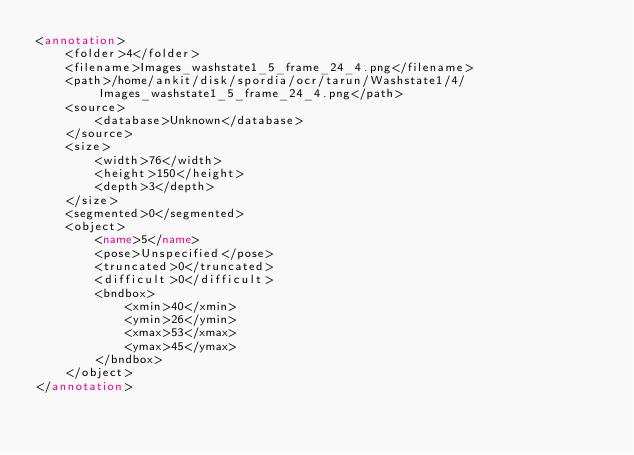<code> <loc_0><loc_0><loc_500><loc_500><_XML_><annotation>
	<folder>4</folder>
	<filename>Images_washstate1_5_frame_24_4.png</filename>
	<path>/home/ankit/disk/spordia/ocr/tarun/Washstate1/4/Images_washstate1_5_frame_24_4.png</path>
	<source>
		<database>Unknown</database>
	</source>
	<size>
		<width>76</width>
		<height>150</height>
		<depth>3</depth>
	</size>
	<segmented>0</segmented>
	<object>
		<name>5</name>
		<pose>Unspecified</pose>
		<truncated>0</truncated>
		<difficult>0</difficult>
		<bndbox>
			<xmin>40</xmin>
			<ymin>26</ymin>
			<xmax>53</xmax>
			<ymax>45</ymax>
		</bndbox>
	</object>
</annotation>
</code> 